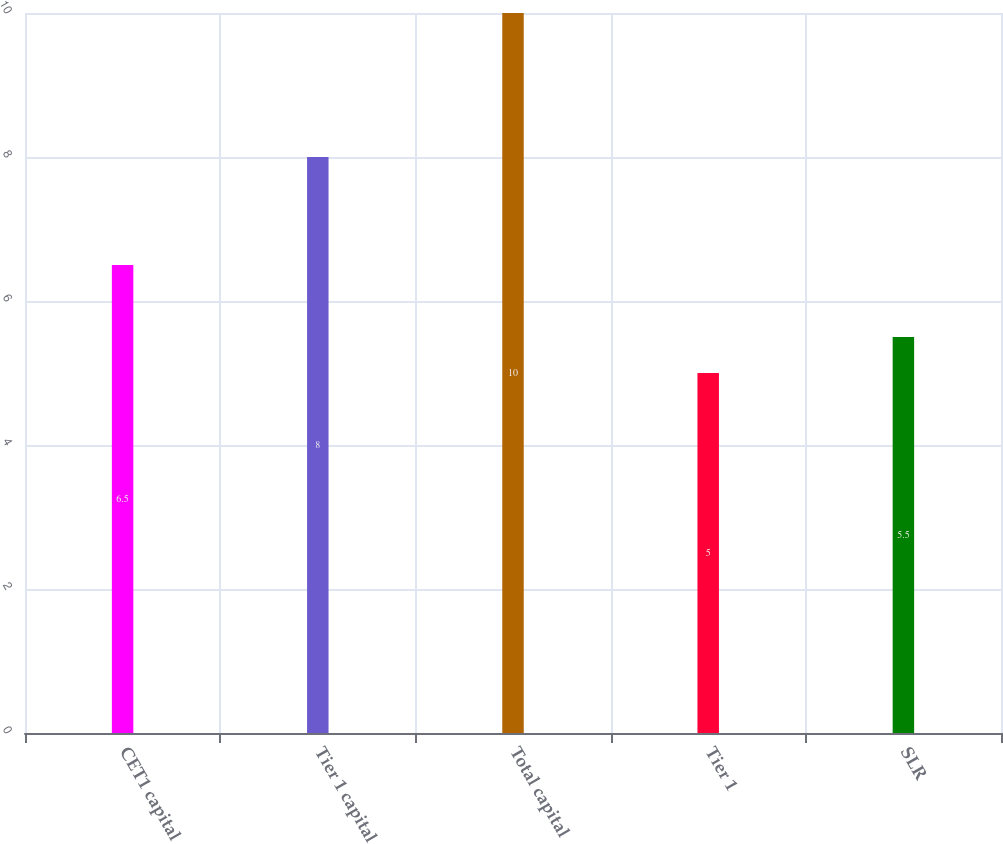Convert chart. <chart><loc_0><loc_0><loc_500><loc_500><bar_chart><fcel>CET1 capital<fcel>Tier 1 capital<fcel>Total capital<fcel>Tier 1<fcel>SLR<nl><fcel>6.5<fcel>8<fcel>10<fcel>5<fcel>5.5<nl></chart> 